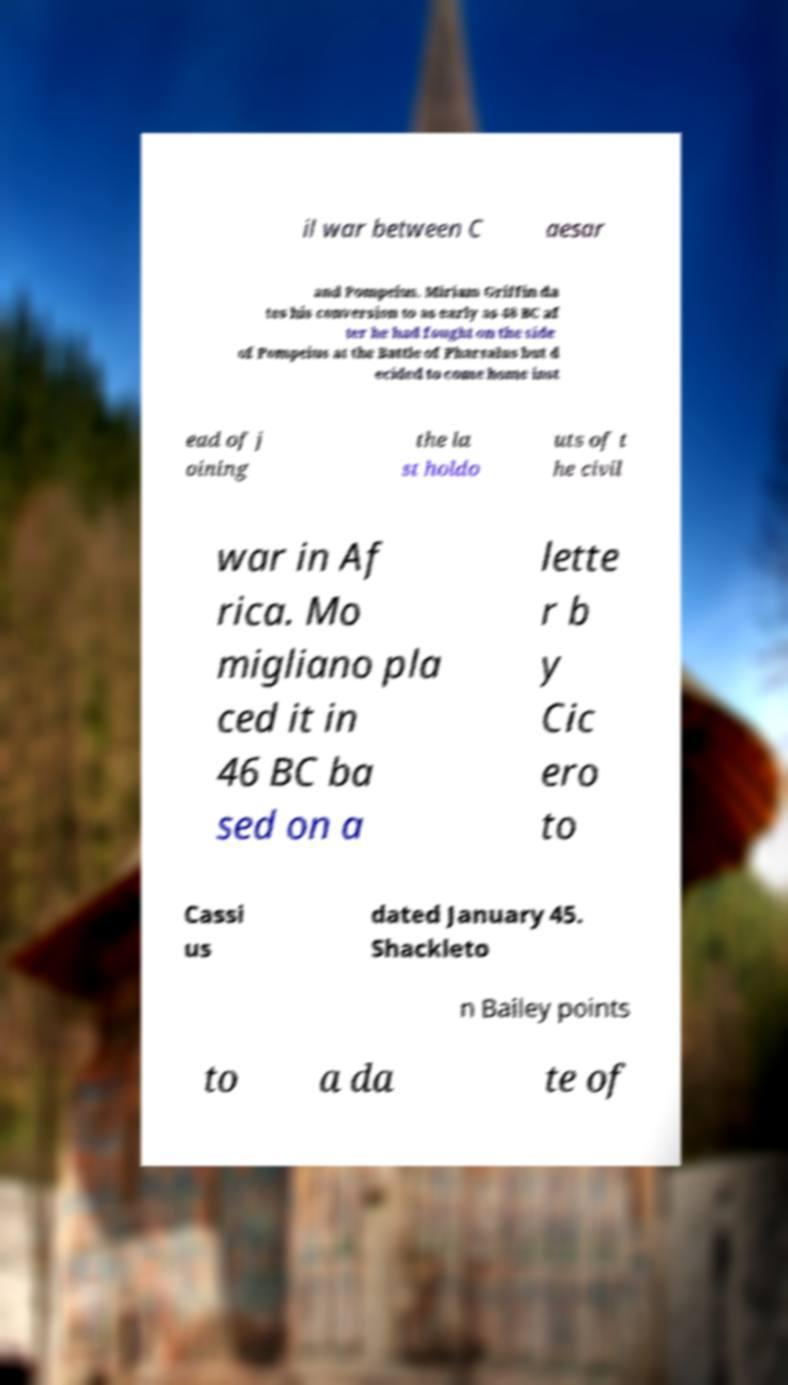Can you accurately transcribe the text from the provided image for me? il war between C aesar and Pompeius. Miriam Griffin da tes his conversion to as early as 48 BC af ter he had fought on the side of Pompeius at the Battle of Pharsalus but d ecided to come home inst ead of j oining the la st holdo uts of t he civil war in Af rica. Mo migliano pla ced it in 46 BC ba sed on a lette r b y Cic ero to Cassi us dated January 45. Shackleto n Bailey points to a da te of 